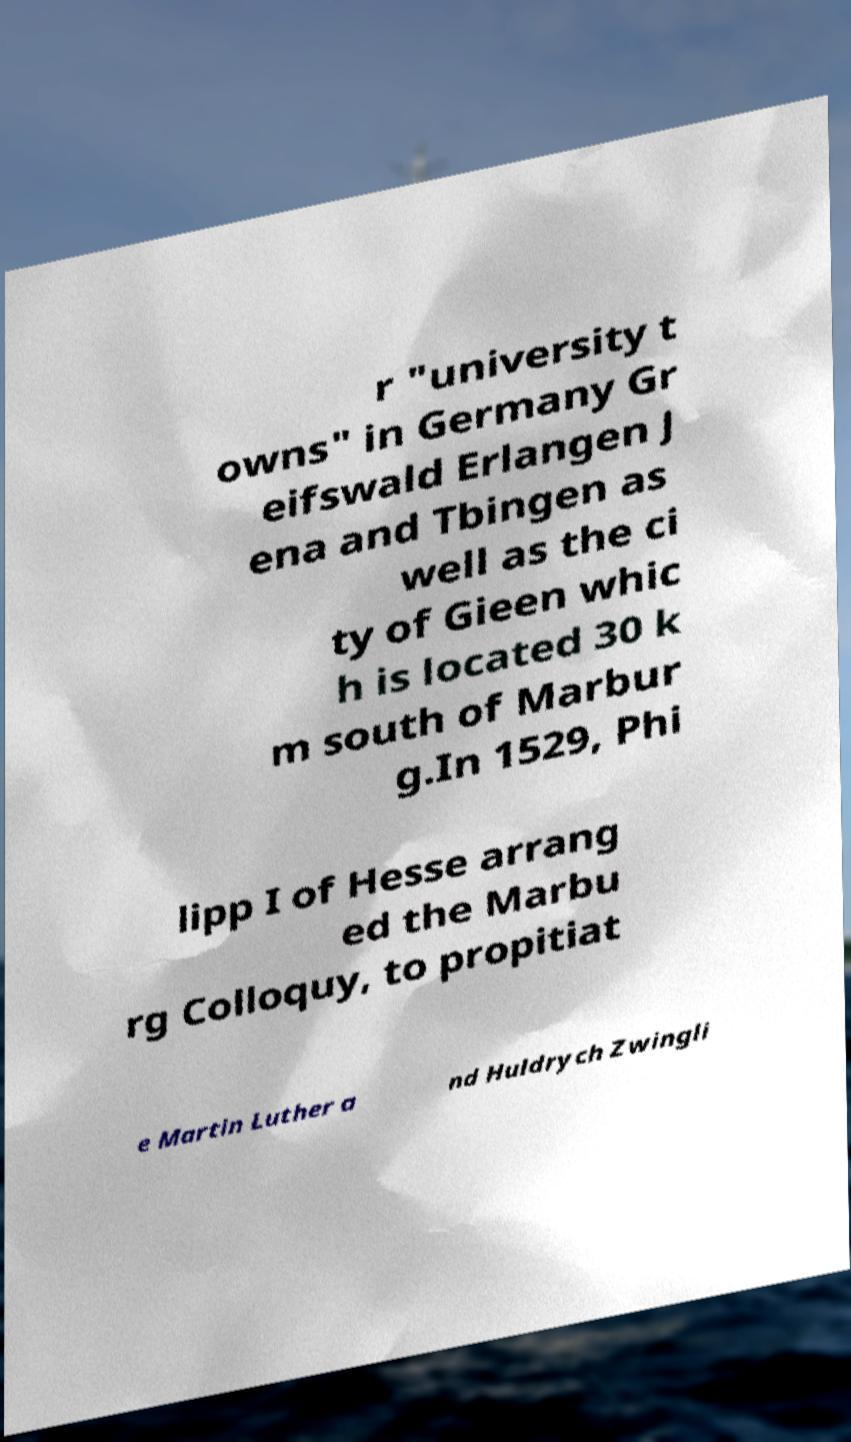Please read and relay the text visible in this image. What does it say? r "university t owns" in Germany Gr eifswald Erlangen J ena and Tbingen as well as the ci ty of Gieen whic h is located 30 k m south of Marbur g.In 1529, Phi lipp I of Hesse arrang ed the Marbu rg Colloquy, to propitiat e Martin Luther a nd Huldrych Zwingli 